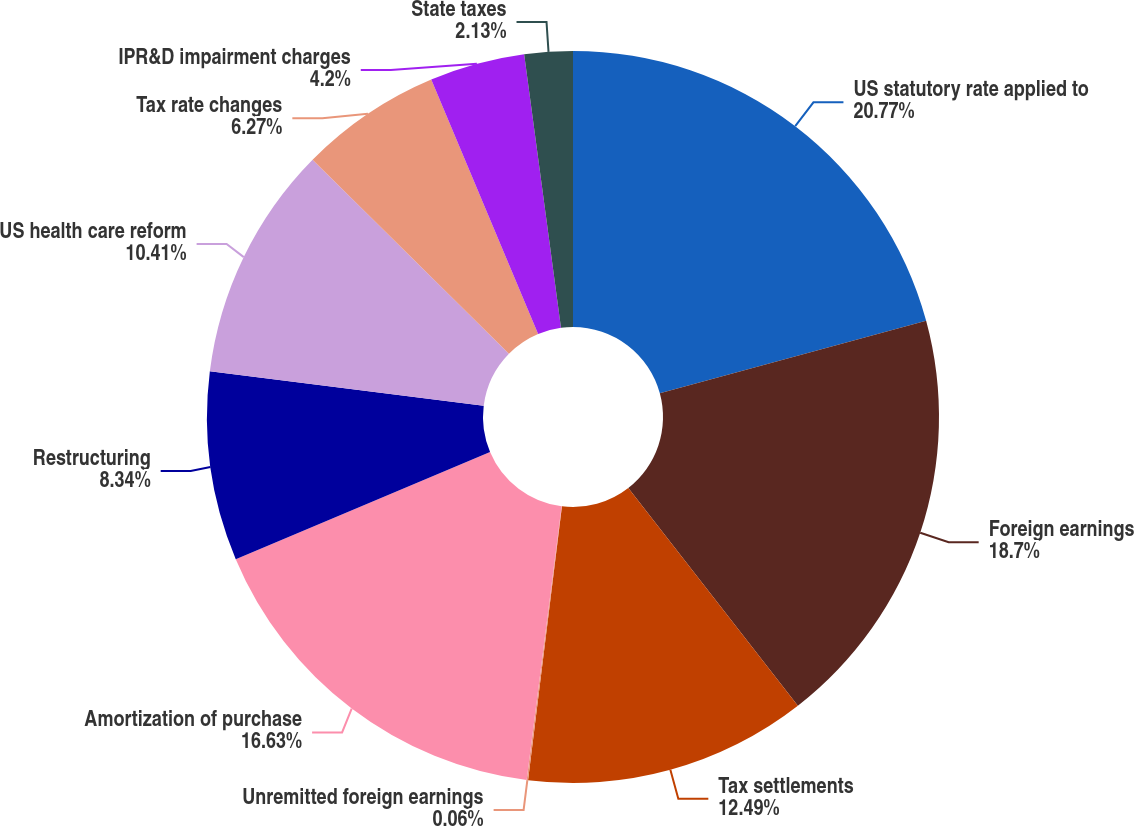Convert chart to OTSL. <chart><loc_0><loc_0><loc_500><loc_500><pie_chart><fcel>US statutory rate applied to<fcel>Foreign earnings<fcel>Tax settlements<fcel>Unremitted foreign earnings<fcel>Amortization of purchase<fcel>Restructuring<fcel>US health care reform<fcel>Tax rate changes<fcel>IPR&D impairment charges<fcel>State taxes<nl><fcel>20.77%<fcel>18.7%<fcel>12.49%<fcel>0.06%<fcel>16.63%<fcel>8.34%<fcel>10.41%<fcel>6.27%<fcel>4.2%<fcel>2.13%<nl></chart> 